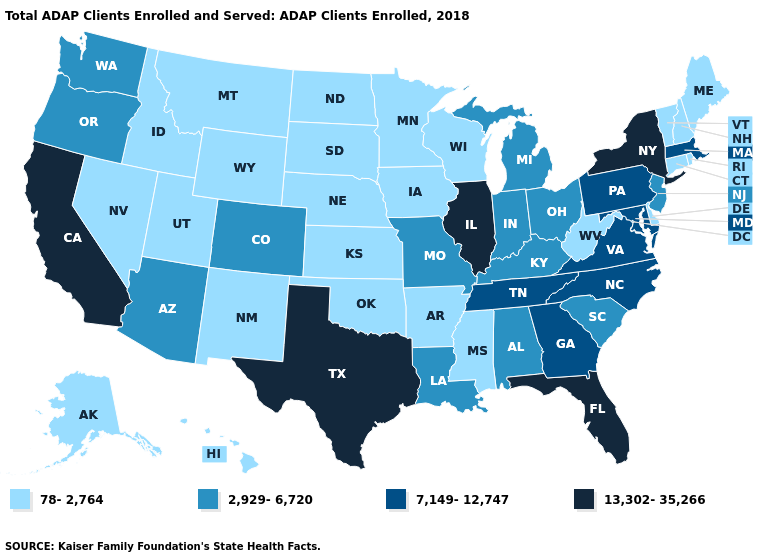Name the states that have a value in the range 2,929-6,720?
Concise answer only. Alabama, Arizona, Colorado, Indiana, Kentucky, Louisiana, Michigan, Missouri, New Jersey, Ohio, Oregon, South Carolina, Washington. What is the value of Nevada?
Answer briefly. 78-2,764. Name the states that have a value in the range 2,929-6,720?
Write a very short answer. Alabama, Arizona, Colorado, Indiana, Kentucky, Louisiana, Michigan, Missouri, New Jersey, Ohio, Oregon, South Carolina, Washington. Does Florida have the highest value in the South?
Quick response, please. Yes. What is the value of Colorado?
Write a very short answer. 2,929-6,720. Among the states that border Massachusetts , which have the lowest value?
Answer briefly. Connecticut, New Hampshire, Rhode Island, Vermont. Does the map have missing data?
Short answer required. No. Name the states that have a value in the range 7,149-12,747?
Answer briefly. Georgia, Maryland, Massachusetts, North Carolina, Pennsylvania, Tennessee, Virginia. What is the highest value in the USA?
Quick response, please. 13,302-35,266. Which states have the lowest value in the MidWest?
Answer briefly. Iowa, Kansas, Minnesota, Nebraska, North Dakota, South Dakota, Wisconsin. Does Colorado have the lowest value in the USA?
Answer briefly. No. What is the value of Hawaii?
Short answer required. 78-2,764. Name the states that have a value in the range 13,302-35,266?
Quick response, please. California, Florida, Illinois, New York, Texas. Which states have the lowest value in the USA?
Be succinct. Alaska, Arkansas, Connecticut, Delaware, Hawaii, Idaho, Iowa, Kansas, Maine, Minnesota, Mississippi, Montana, Nebraska, Nevada, New Hampshire, New Mexico, North Dakota, Oklahoma, Rhode Island, South Dakota, Utah, Vermont, West Virginia, Wisconsin, Wyoming. What is the highest value in states that border Pennsylvania?
Be succinct. 13,302-35,266. 